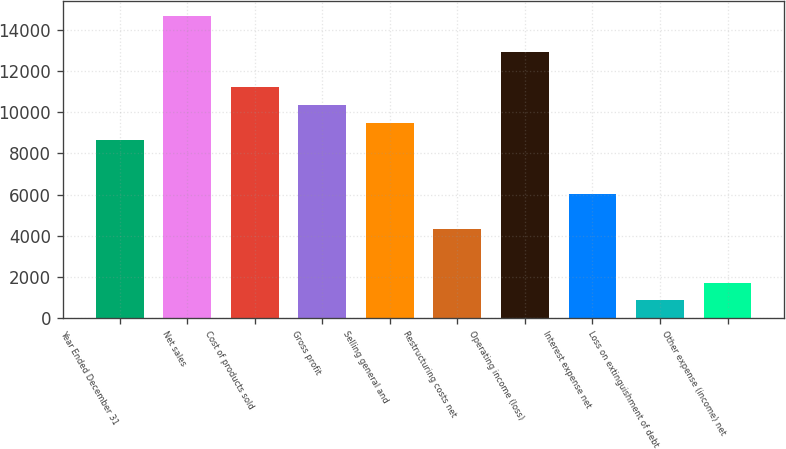Convert chart. <chart><loc_0><loc_0><loc_500><loc_500><bar_chart><fcel>Year Ended December 31<fcel>Net sales<fcel>Cost of products sold<fcel>Gross profit<fcel>Selling general and<fcel>Restructuring costs net<fcel>Operating income (loss)<fcel>Interest expense net<fcel>Loss on extinguishment of debt<fcel>Other expense (income) net<nl><fcel>8630.87<fcel>14672.3<fcel>11220<fcel>10357<fcel>9493.93<fcel>4315.57<fcel>12946.2<fcel>6041.69<fcel>863.33<fcel>1726.39<nl></chart> 